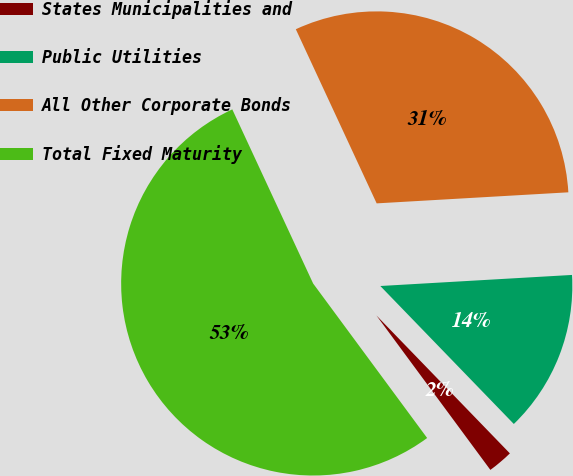Convert chart to OTSL. <chart><loc_0><loc_0><loc_500><loc_500><pie_chart><fcel>States Municipalities and<fcel>Public Utilities<fcel>All Other Corporate Bonds<fcel>Total Fixed Maturity<nl><fcel>2.12%<fcel>13.68%<fcel>31.0%<fcel>53.2%<nl></chart> 